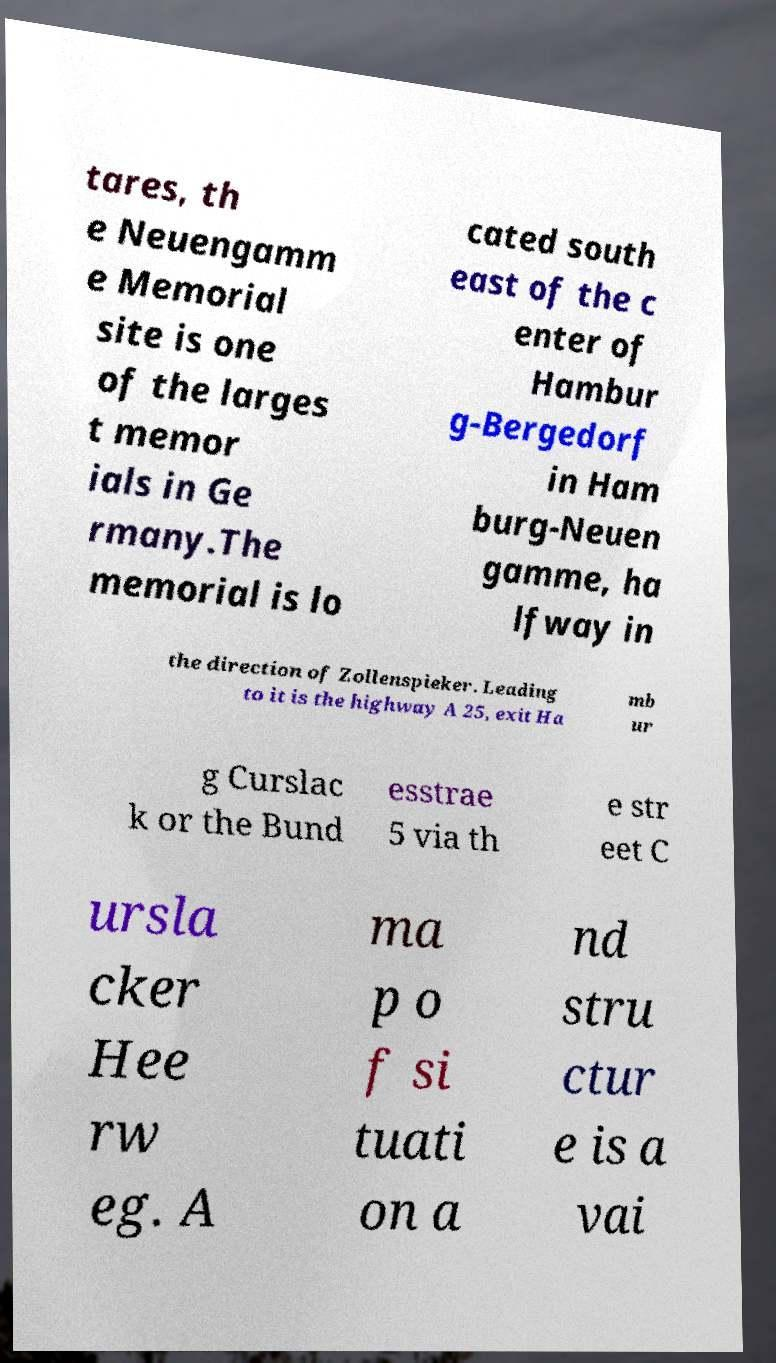There's text embedded in this image that I need extracted. Can you transcribe it verbatim? tares, th e Neuengamm e Memorial site is one of the larges t memor ials in Ge rmany.The memorial is lo cated south east of the c enter of Hambur g-Bergedorf in Ham burg-Neuen gamme, ha lfway in the direction of Zollenspieker. Leading to it is the highway A 25, exit Ha mb ur g Curslac k or the Bund esstrae 5 via th e str eet C ursla cker Hee rw eg. A ma p o f si tuati on a nd stru ctur e is a vai 